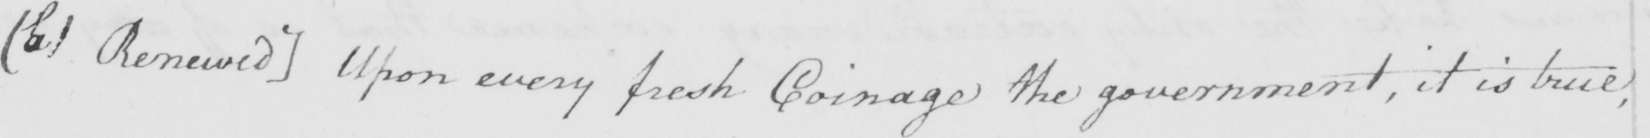What text is written in this handwritten line? [  ( b )  Renewed ]  Upon every fresh coinage the government , it is true , 